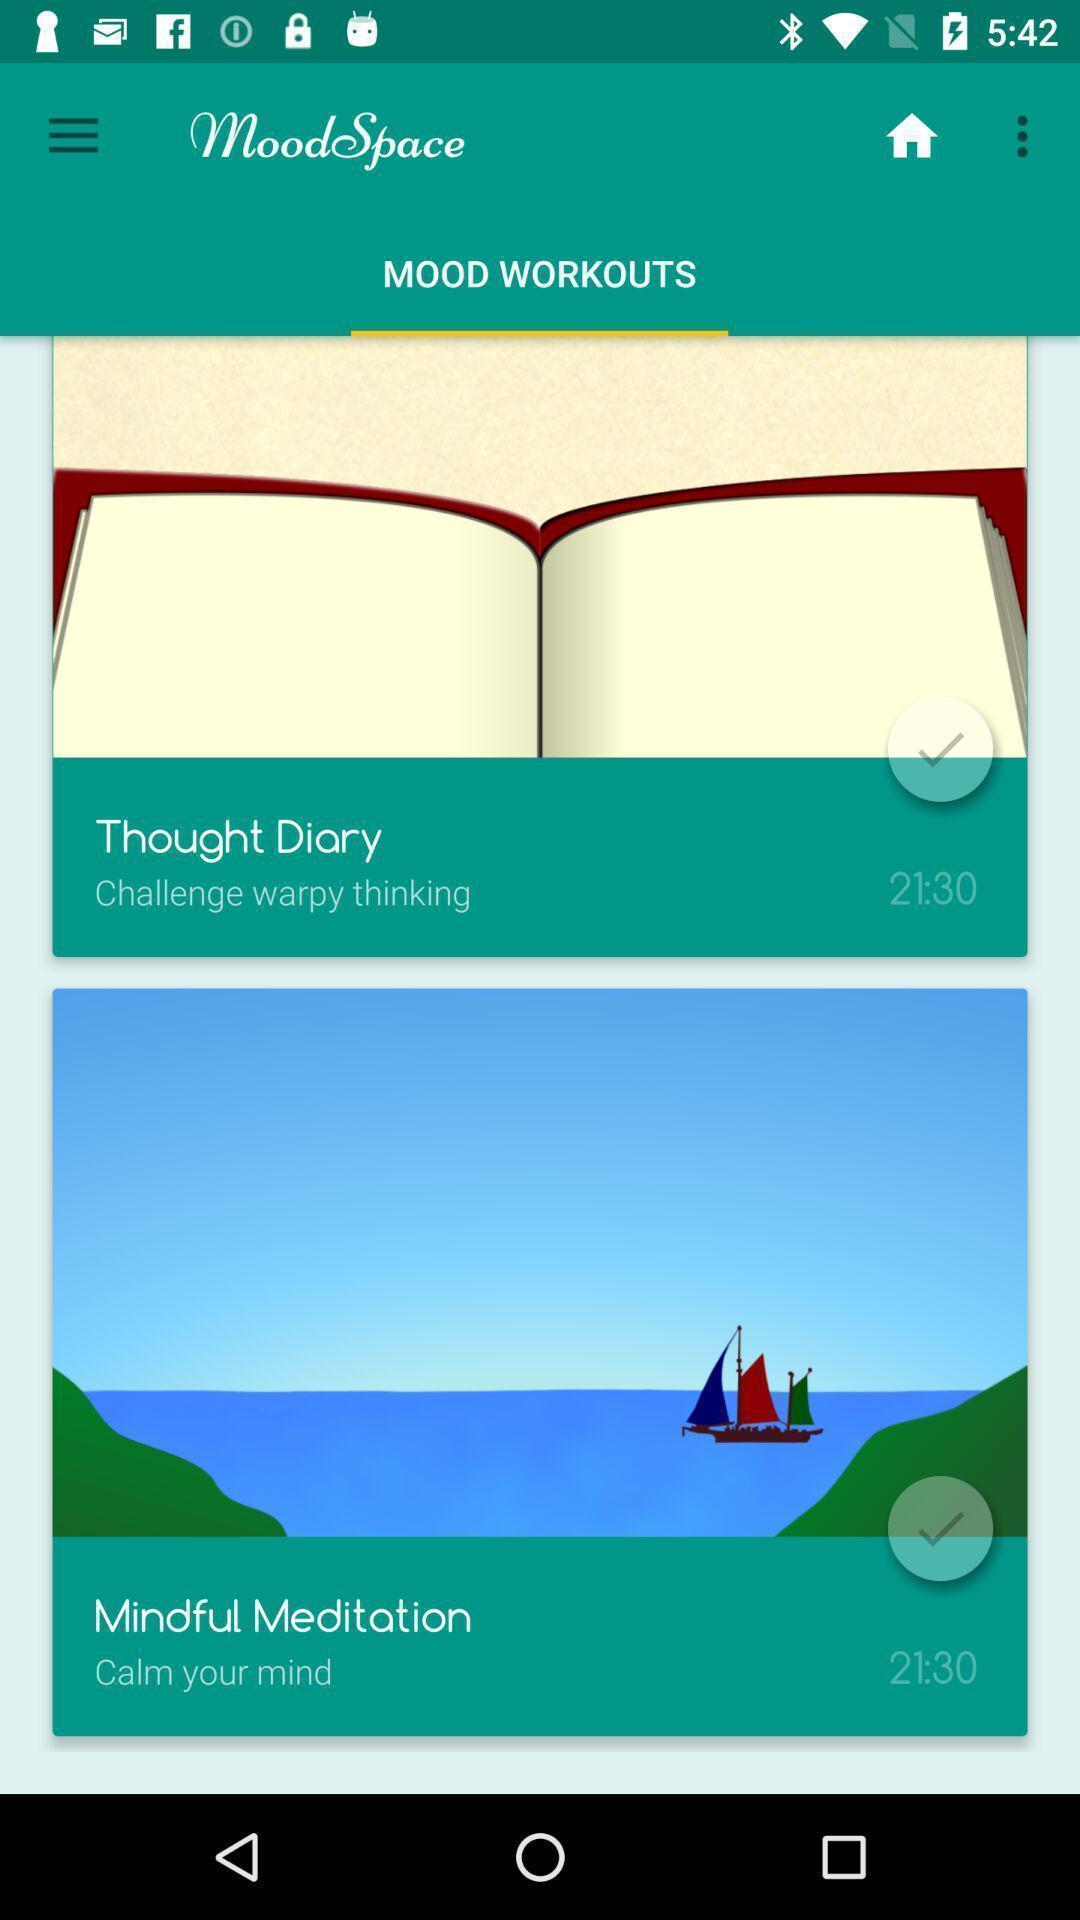Provide a textual representation of this image. Screen displaying multiple options in an e-counselling application. 